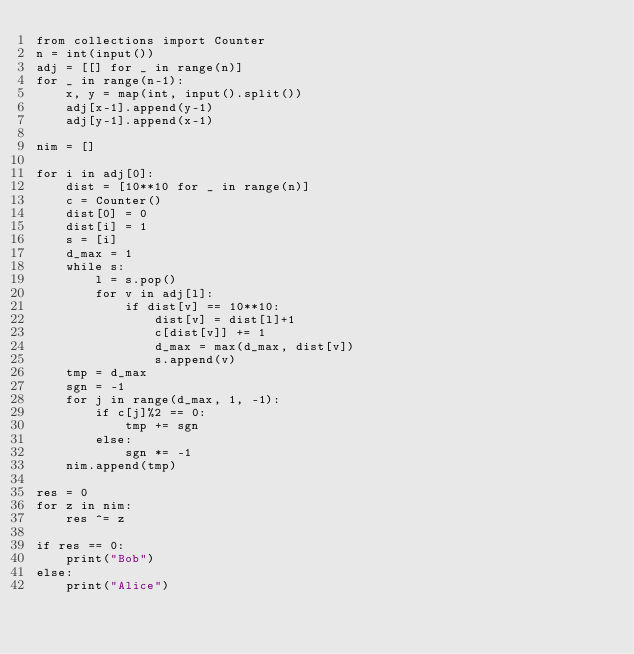Convert code to text. <code><loc_0><loc_0><loc_500><loc_500><_Python_>from collections import Counter
n = int(input())
adj = [[] for _ in range(n)]
for _ in range(n-1):
	x, y = map(int, input().split())
	adj[x-1].append(y-1)
	adj[y-1].append(x-1)

nim = []

for i in adj[0]:
	dist = [10**10 for _ in range(n)]
	c = Counter()
	dist[0] = 0
	dist[i] = 1
	s = [i]
	d_max = 1
	while s:
		l = s.pop()
		for v in adj[l]:
			if dist[v] == 10**10:
				dist[v] = dist[l]+1
				c[dist[v]] += 1
				d_max = max(d_max, dist[v])
				s.append(v)
	tmp = d_max
	sgn = -1
	for j in range(d_max, 1, -1):
		if c[j]%2 == 0:
			tmp += sgn
		else:
			sgn *= -1
	nim.append(tmp)

res = 0
for z in nim:
	res ^= z

if res == 0:
	print("Bob")
else:
	print("Alice")</code> 